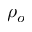Convert formula to latex. <formula><loc_0><loc_0><loc_500><loc_500>\rho _ { o }</formula> 